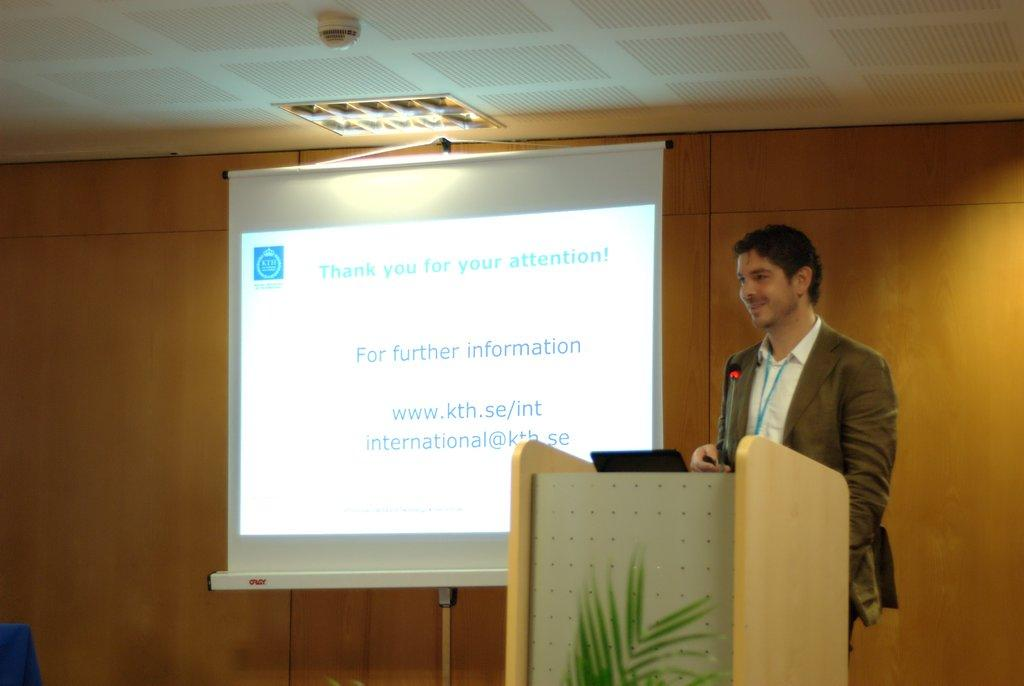Provide a one-sentence caption for the provided image. A man at a podium uses a powerpoint for a presentation and is thanking the audience for their participation. 